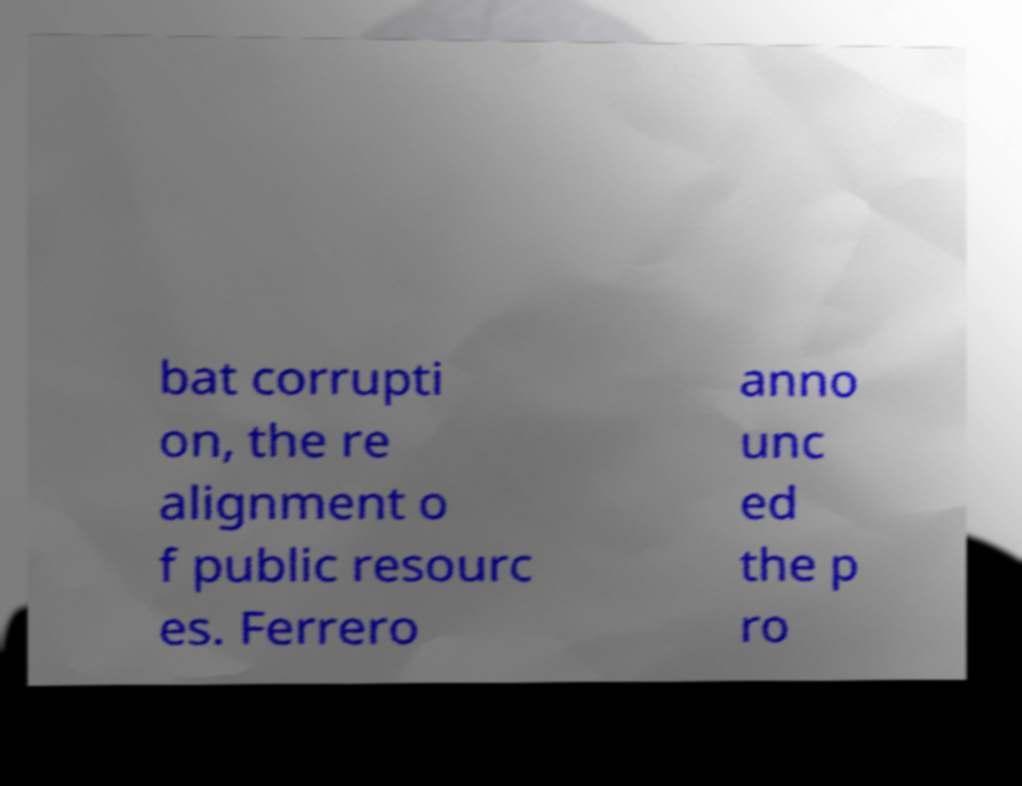Could you extract and type out the text from this image? bat corrupti on, the re alignment o f public resourc es. Ferrero anno unc ed the p ro 